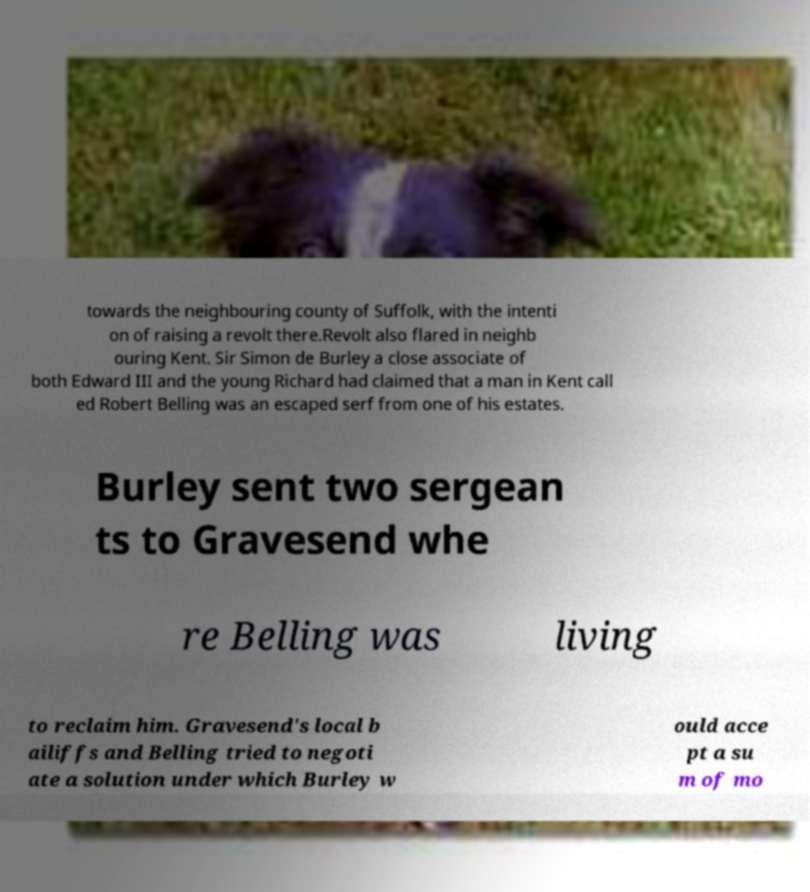Please identify and transcribe the text found in this image. towards the neighbouring county of Suffolk, with the intenti on of raising a revolt there.Revolt also flared in neighb ouring Kent. Sir Simon de Burley a close associate of both Edward III and the young Richard had claimed that a man in Kent call ed Robert Belling was an escaped serf from one of his estates. Burley sent two sergean ts to Gravesend whe re Belling was living to reclaim him. Gravesend's local b ailiffs and Belling tried to negoti ate a solution under which Burley w ould acce pt a su m of mo 